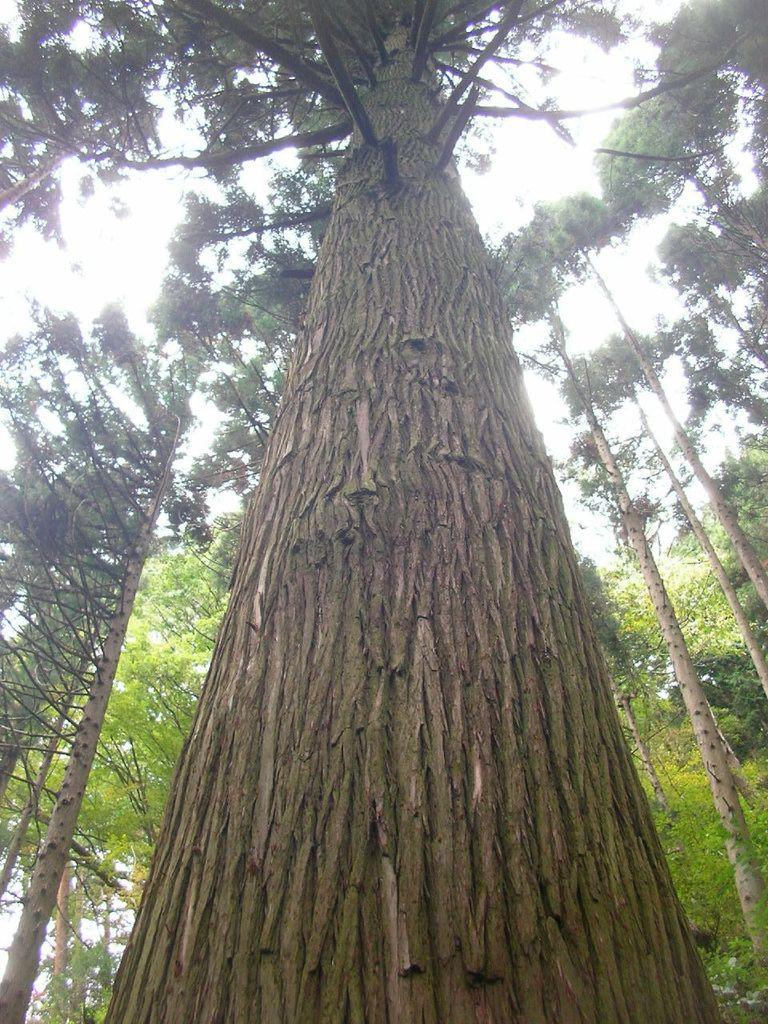What is the main subject of the image? There is a tree in the image. Can you describe the color of the tree? The tree is brown and green in color. What else can be seen in the background of the image? There are other trees in the background of the image, and the sky is visible as well. What color are the background trees? The background trees are green in color. What is the opinion of the tree about the lunch served in the image? There is no lunch present in the image, and trees do not have opinions. 